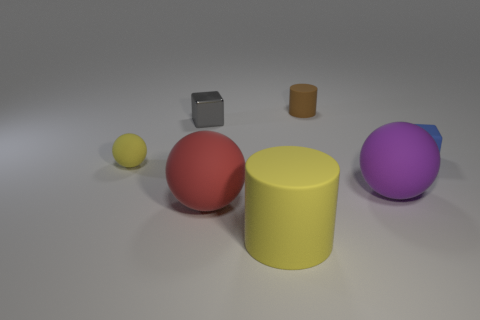Add 2 brown cylinders. How many objects exist? 9 Subtract all balls. How many objects are left? 4 Subtract 0 red cylinders. How many objects are left? 7 Subtract all purple blocks. Subtract all small blue matte things. How many objects are left? 6 Add 2 purple matte spheres. How many purple matte spheres are left? 3 Add 1 large yellow spheres. How many large yellow spheres exist? 1 